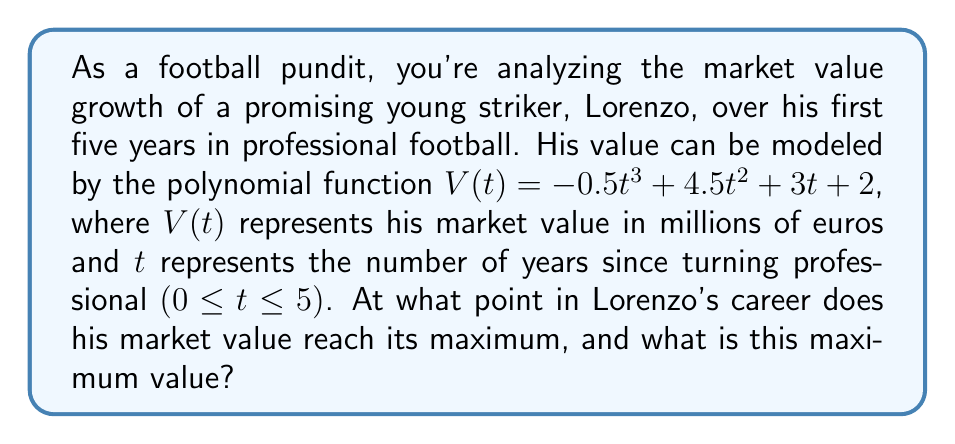Can you answer this question? To find the maximum point of Lorenzo's market value, we need to follow these steps:

1) First, we need to find the derivative of the function $V(t)$:
   $$V'(t) = -1.5t^2 + 9t + 3$$

2) The maximum point occurs where the derivative equals zero. So, we set $V'(t) = 0$:
   $$-1.5t^2 + 9t + 3 = 0$$

3) This is a quadratic equation. We can solve it using the quadratic formula:
   $$t = \frac{-b \pm \sqrt{b^2 - 4ac}}{2a}$$
   where $a = -1.5$, $b = 9$, and $c = 3$

4) Plugging in these values:
   $$t = \frac{-9 \pm \sqrt{81 - 4(-1.5)(3)}}{2(-1.5)} = \frac{-9 \pm \sqrt{99}}{-3}$$

5) Simplifying:
   $$t = \frac{9 \mp \sqrt{99}}{3} = 3 \mp \frac{\sqrt{99}}{3}$$

6) This gives us two solutions: $t \approx 4.31$ and $t \approx 1.69$

7) Since we're looking for a maximum, and the coefficient of $t^3$ in the original function is negative, the larger t-value (4.31) will give us the maximum.

8) To find the maximum value, we plug $t = 4.31$ back into the original function:
   $$V(4.31) = -0.5(4.31)^3 + 4.5(4.31)^2 + 3(4.31) + 2 \approx 40.06$$

Therefore, Lorenzo's market value reaches its maximum after approximately 4.31 years, at which point his value is about 40.06 million euros.
Answer: Lorenzo's market value reaches its maximum after approximately 4.31 years, with a value of about 40.06 million euros. 